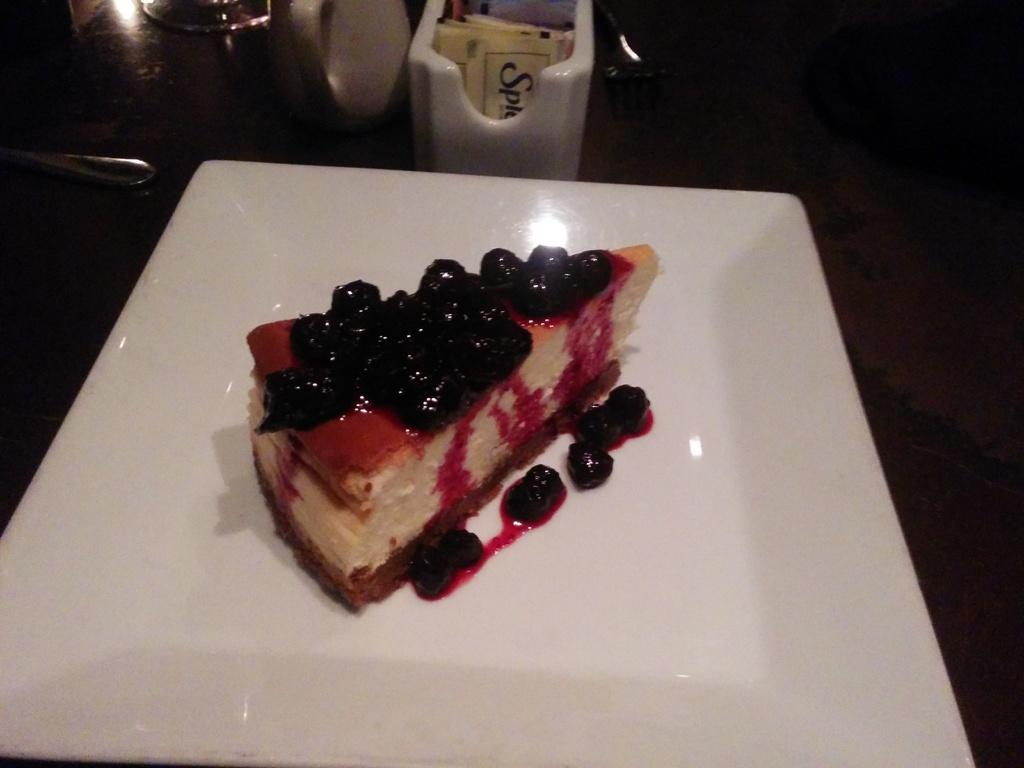What type of food is on the table in the image? There is a dessert on the table in the image. What else can be seen in the background of the image? There are other objects on a stand in the background. What utensil is visible in the image? There is a spoon visible in the image. What behavior is exhibited by the month in the image? There is no month present in the image, as it is a still image and not a representation of time. 